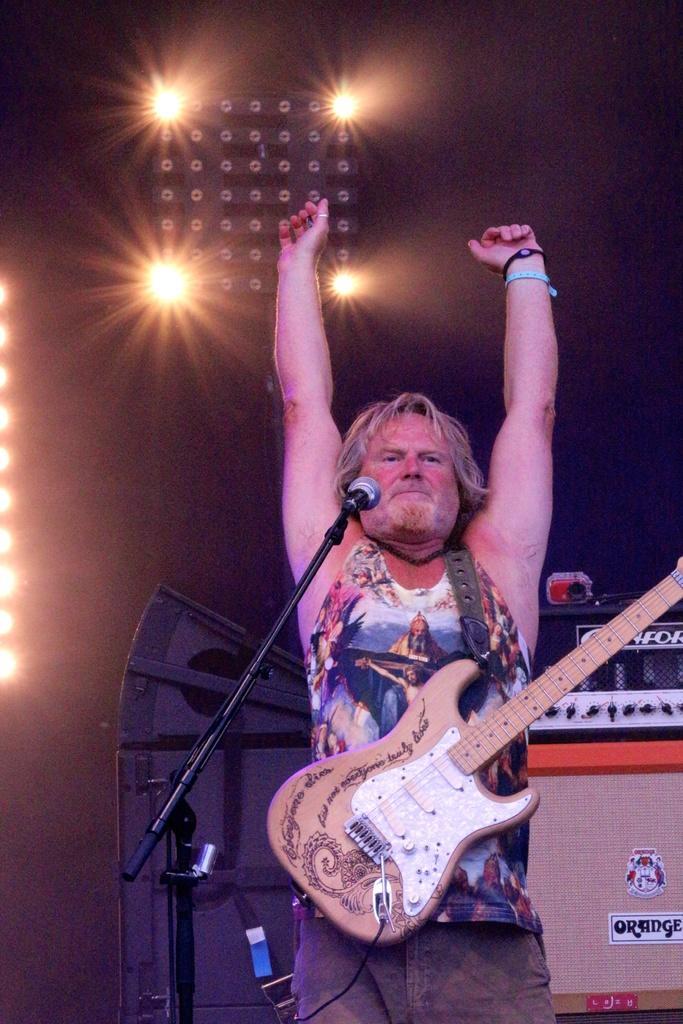In one or two sentences, can you explain what this image depicts? This is the picture of man having a guitar in front of the man there is a microphone with stand. Behind the man there are some music systems and a pole with lights. 